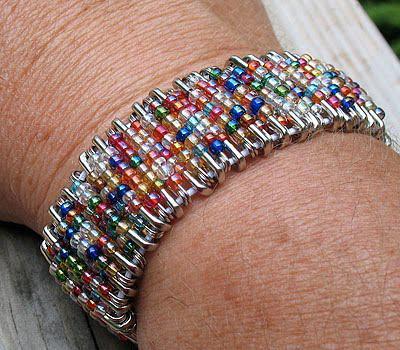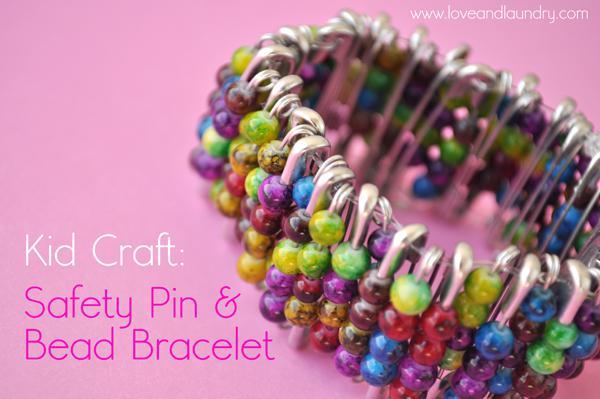The first image is the image on the left, the second image is the image on the right. For the images displayed, is the sentence "there is a human wearing a bracelet in each image." factually correct? Answer yes or no. No. The first image is the image on the left, the second image is the image on the right. For the images shown, is this caption "An image shows an unworn bracelet made of silver safety pins strung with different bead colors." true? Answer yes or no. Yes. 